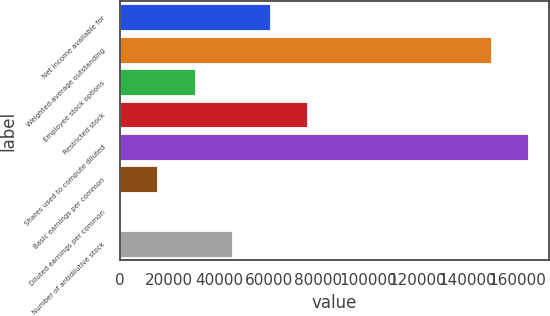<chart> <loc_0><loc_0><loc_500><loc_500><bar_chart><fcel>Net income available for<fcel>Weighted-average outstanding<fcel>Employee stock options<fcel>Restricted stock<fcel>Shares used to compute diluted<fcel>Basic earnings per common<fcel>Diluted earnings per common<fcel>Number of antidilutive stock<nl><fcel>60461.9<fcel>149455<fcel>30235.2<fcel>75575.2<fcel>164568<fcel>15121.8<fcel>8.44<fcel>45348.5<nl></chart> 